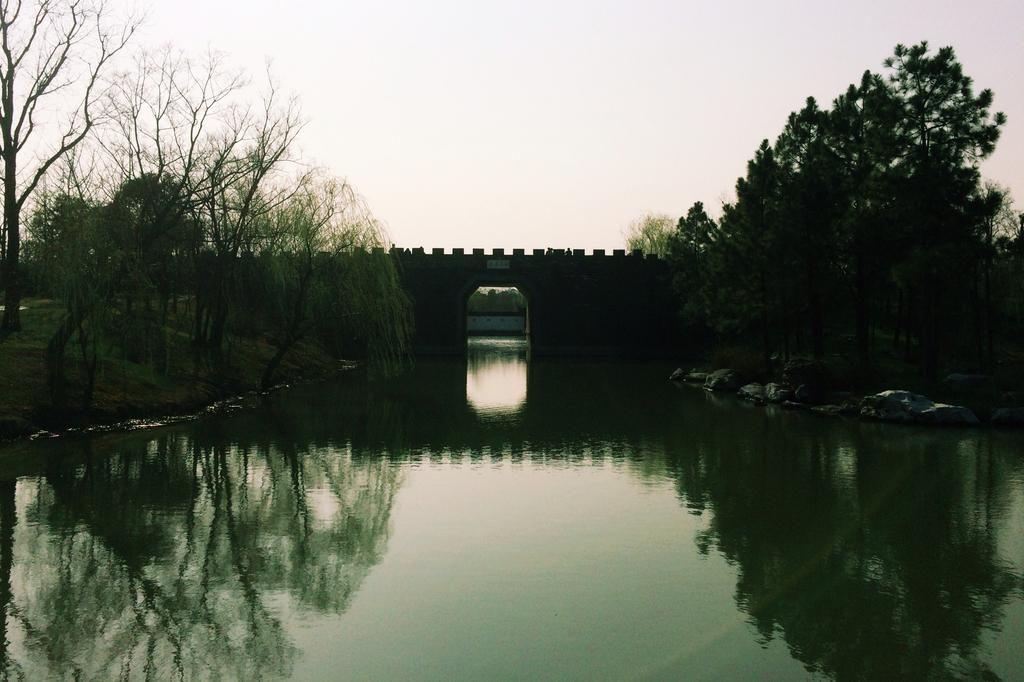What type of natural elements can be seen in the image? There are trees and water visible in the image. What man-made structure is present in the image? There is a bridge in the image. What type of terrain is visible in the image? There are rocks in the image. What is the color of the sky in the image? The sky appears to be white in color. Can you see any goldfish swimming in the water in the image? No, there are no goldfish visible in the water in the image. Is there a seashore visible in the image? No, there is no seashore present in the image; it features trees, water, a bridge, rocks, and a white sky. 